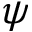<formula> <loc_0><loc_0><loc_500><loc_500>\psi</formula> 